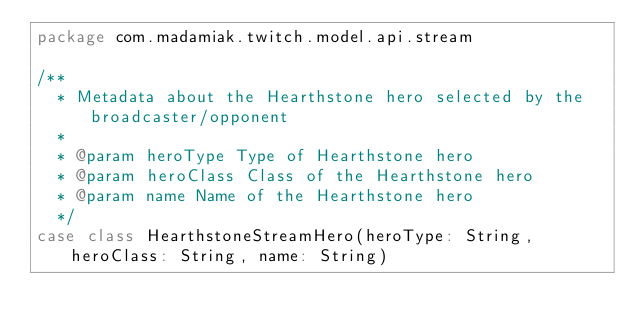Convert code to text. <code><loc_0><loc_0><loc_500><loc_500><_Scala_>package com.madamiak.twitch.model.api.stream

/**
  * Metadata about the Hearthstone hero selected by the broadcaster/opponent
  *
  * @param heroType Type of Hearthstone hero
  * @param heroClass Class of the Hearthstone hero
  * @param name Name of the Hearthstone hero
  */
case class HearthstoneStreamHero(heroType: String, heroClass: String, name: String)
</code> 